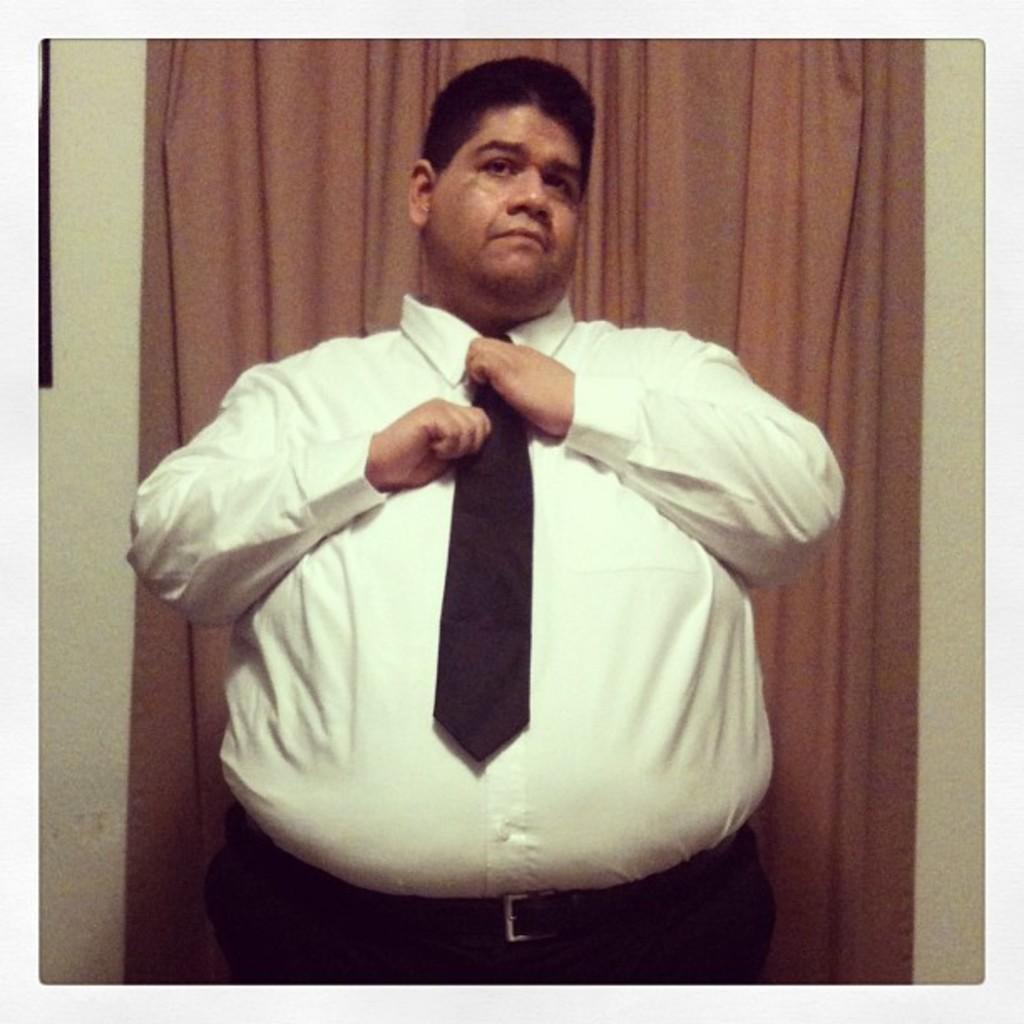How would you summarize this image in a sentence or two? In this image we can see a person tying a tie, behind him there is a wall, and a curtain. 